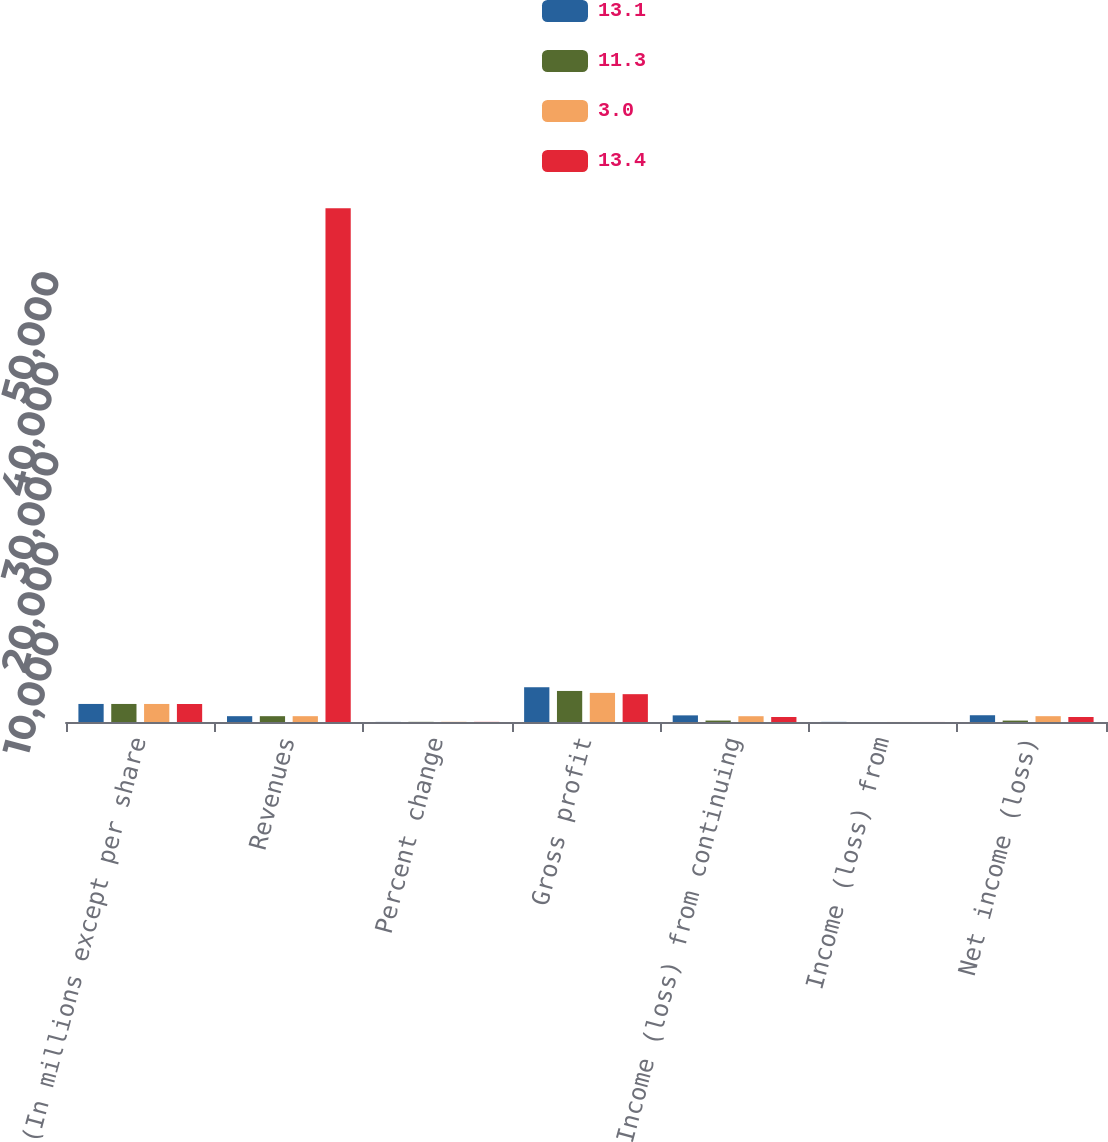<chart> <loc_0><loc_0><loc_500><loc_500><stacked_bar_chart><ecel><fcel>(In millions except per share<fcel>Revenues<fcel>Percent change<fcel>Gross profit<fcel>Income (loss) from continuing<fcel>Income (loss) from<fcel>Net income (loss)<nl><fcel>13.1<fcel>2006<fcel>647<fcel>9.9<fcel>3862<fcel>737<fcel>14<fcel>751<nl><fcel>11.3<fcel>2005<fcel>647<fcel>15.8<fcel>3450<fcel>160<fcel>3<fcel>157<nl><fcel>3<fcel>2004<fcel>647<fcel>21.3<fcel>3235<fcel>643<fcel>4<fcel>647<nl><fcel>13.4<fcel>2003<fcel>57077<fcel>14.3<fcel>3092<fcel>559<fcel>4<fcel>555<nl></chart> 